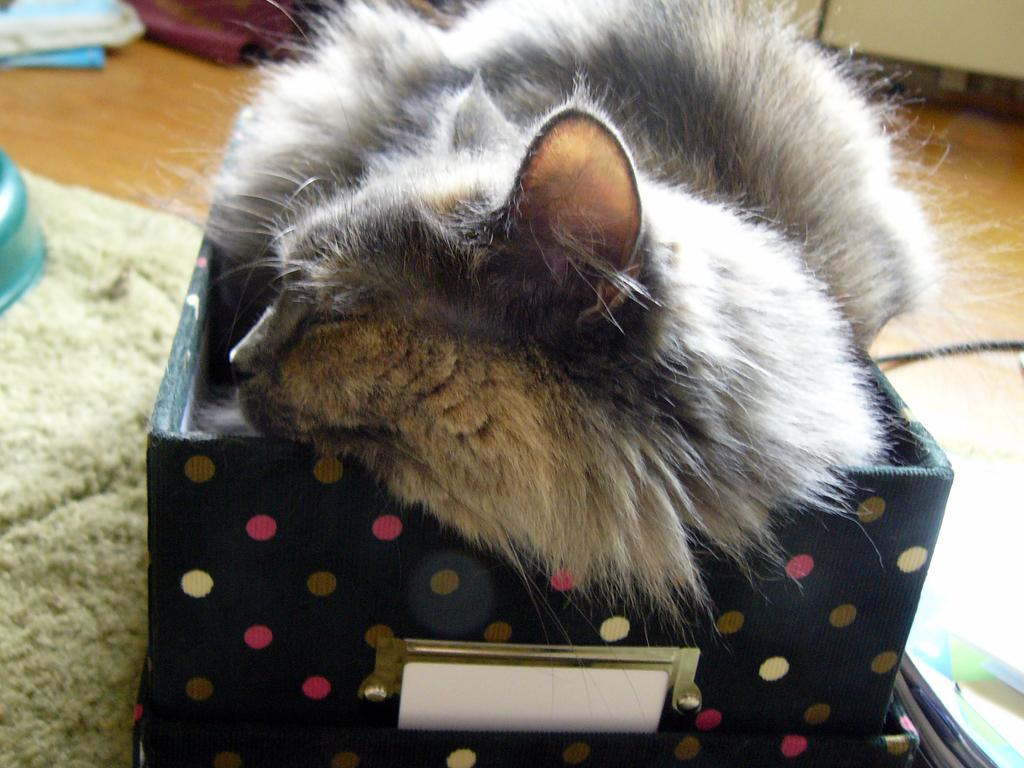What type of animal is in the image? There is a cat in the image. Where is the cat located? The cat is in a cardboard box. What colors can be seen on the cat? The cat has white and gray coloring. What can be seen in the background of the image? There are objects visible in the background of the image. How many sisters are in the image with the cat? There are no sisters present in the image; it only features a cat in a cardboard box. What type of sand can be seen in the image? There is no sand present in the image. 